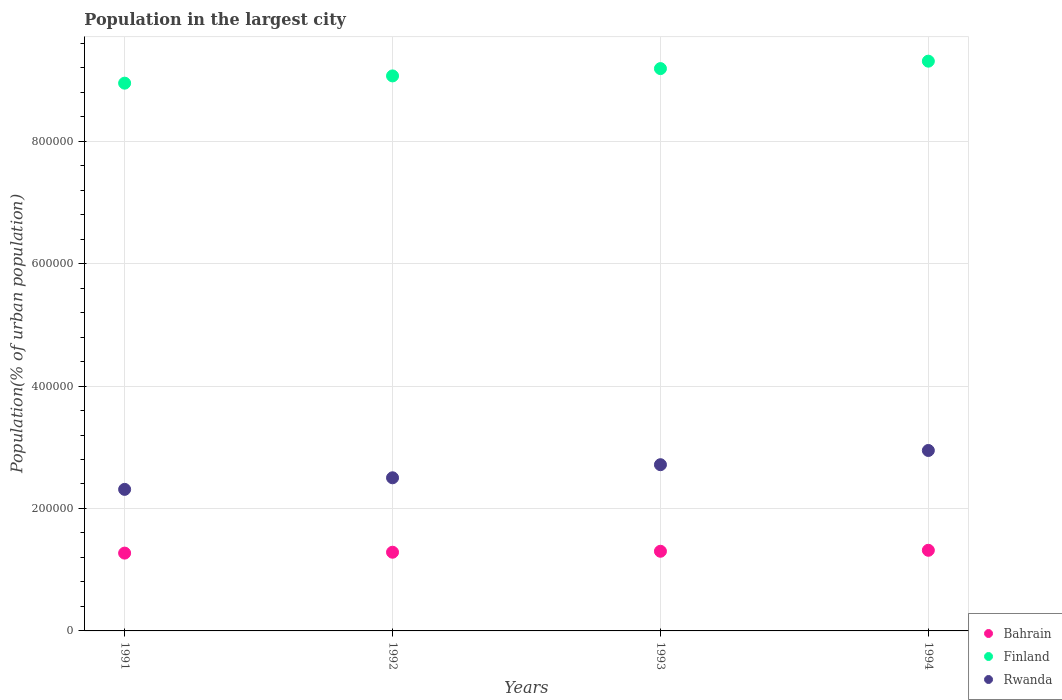What is the population in the largest city in Finland in 1992?
Offer a terse response. 9.07e+05. Across all years, what is the maximum population in the largest city in Bahrain?
Keep it short and to the point. 1.32e+05. Across all years, what is the minimum population in the largest city in Rwanda?
Make the answer very short. 2.31e+05. What is the total population in the largest city in Rwanda in the graph?
Provide a succinct answer. 1.05e+06. What is the difference between the population in the largest city in Rwanda in 1991 and that in 1993?
Your answer should be very brief. -4.03e+04. What is the difference between the population in the largest city in Bahrain in 1993 and the population in the largest city in Rwanda in 1992?
Ensure brevity in your answer.  -1.20e+05. What is the average population in the largest city in Bahrain per year?
Make the answer very short. 1.29e+05. In the year 1992, what is the difference between the population in the largest city in Rwanda and population in the largest city in Bahrain?
Your answer should be compact. 1.22e+05. What is the ratio of the population in the largest city in Bahrain in 1993 to that in 1994?
Keep it short and to the point. 0.99. Is the population in the largest city in Bahrain in 1991 less than that in 1994?
Your answer should be very brief. Yes. Is the difference between the population in the largest city in Rwanda in 1991 and 1994 greater than the difference between the population in the largest city in Bahrain in 1991 and 1994?
Keep it short and to the point. No. What is the difference between the highest and the second highest population in the largest city in Bahrain?
Your response must be concise. 1595. What is the difference between the highest and the lowest population in the largest city in Bahrain?
Your answer should be compact. 4609. In how many years, is the population in the largest city in Finland greater than the average population in the largest city in Finland taken over all years?
Offer a terse response. 2. Does the population in the largest city in Rwanda monotonically increase over the years?
Give a very brief answer. Yes. Is the population in the largest city in Finland strictly greater than the population in the largest city in Rwanda over the years?
Keep it short and to the point. Yes. Is the population in the largest city in Bahrain strictly less than the population in the largest city in Rwanda over the years?
Give a very brief answer. Yes. How many dotlines are there?
Ensure brevity in your answer.  3. Are the values on the major ticks of Y-axis written in scientific E-notation?
Give a very brief answer. No. Where does the legend appear in the graph?
Offer a very short reply. Bottom right. How many legend labels are there?
Provide a succinct answer. 3. What is the title of the graph?
Provide a short and direct response. Population in the largest city. What is the label or title of the X-axis?
Give a very brief answer. Years. What is the label or title of the Y-axis?
Offer a terse response. Population(% of urban population). What is the Population(% of urban population) of Bahrain in 1991?
Offer a very short reply. 1.27e+05. What is the Population(% of urban population) of Finland in 1991?
Offer a terse response. 8.95e+05. What is the Population(% of urban population) in Rwanda in 1991?
Keep it short and to the point. 2.31e+05. What is the Population(% of urban population) of Bahrain in 1992?
Make the answer very short. 1.29e+05. What is the Population(% of urban population) in Finland in 1992?
Make the answer very short. 9.07e+05. What is the Population(% of urban population) in Rwanda in 1992?
Your answer should be very brief. 2.50e+05. What is the Population(% of urban population) in Bahrain in 1993?
Give a very brief answer. 1.30e+05. What is the Population(% of urban population) of Finland in 1993?
Your answer should be compact. 9.18e+05. What is the Population(% of urban population) of Rwanda in 1993?
Your answer should be compact. 2.72e+05. What is the Population(% of urban population) of Bahrain in 1994?
Your answer should be compact. 1.32e+05. What is the Population(% of urban population) in Finland in 1994?
Give a very brief answer. 9.31e+05. What is the Population(% of urban population) of Rwanda in 1994?
Provide a short and direct response. 2.95e+05. Across all years, what is the maximum Population(% of urban population) in Bahrain?
Your answer should be compact. 1.32e+05. Across all years, what is the maximum Population(% of urban population) of Finland?
Provide a short and direct response. 9.31e+05. Across all years, what is the maximum Population(% of urban population) in Rwanda?
Give a very brief answer. 2.95e+05. Across all years, what is the minimum Population(% of urban population) in Bahrain?
Keep it short and to the point. 1.27e+05. Across all years, what is the minimum Population(% of urban population) of Finland?
Keep it short and to the point. 8.95e+05. Across all years, what is the minimum Population(% of urban population) in Rwanda?
Your answer should be very brief. 2.31e+05. What is the total Population(% of urban population) in Bahrain in the graph?
Offer a very short reply. 5.17e+05. What is the total Population(% of urban population) of Finland in the graph?
Keep it short and to the point. 3.65e+06. What is the total Population(% of urban population) in Rwanda in the graph?
Make the answer very short. 1.05e+06. What is the difference between the Population(% of urban population) of Bahrain in 1991 and that in 1992?
Ensure brevity in your answer.  -1440. What is the difference between the Population(% of urban population) in Finland in 1991 and that in 1992?
Give a very brief answer. -1.18e+04. What is the difference between the Population(% of urban population) in Rwanda in 1991 and that in 1992?
Make the answer very short. -1.89e+04. What is the difference between the Population(% of urban population) of Bahrain in 1991 and that in 1993?
Provide a short and direct response. -3014. What is the difference between the Population(% of urban population) in Finland in 1991 and that in 1993?
Make the answer very short. -2.38e+04. What is the difference between the Population(% of urban population) of Rwanda in 1991 and that in 1993?
Your answer should be very brief. -4.03e+04. What is the difference between the Population(% of urban population) of Bahrain in 1991 and that in 1994?
Provide a succinct answer. -4609. What is the difference between the Population(% of urban population) in Finland in 1991 and that in 1994?
Offer a terse response. -3.59e+04. What is the difference between the Population(% of urban population) of Rwanda in 1991 and that in 1994?
Ensure brevity in your answer.  -6.35e+04. What is the difference between the Population(% of urban population) of Bahrain in 1992 and that in 1993?
Your answer should be compact. -1574. What is the difference between the Population(% of urban population) of Finland in 1992 and that in 1993?
Your response must be concise. -1.20e+04. What is the difference between the Population(% of urban population) in Rwanda in 1992 and that in 1993?
Provide a short and direct response. -2.14e+04. What is the difference between the Population(% of urban population) in Bahrain in 1992 and that in 1994?
Your answer should be very brief. -3169. What is the difference between the Population(% of urban population) of Finland in 1992 and that in 1994?
Provide a succinct answer. -2.41e+04. What is the difference between the Population(% of urban population) in Rwanda in 1992 and that in 1994?
Your answer should be very brief. -4.46e+04. What is the difference between the Population(% of urban population) in Bahrain in 1993 and that in 1994?
Give a very brief answer. -1595. What is the difference between the Population(% of urban population) of Finland in 1993 and that in 1994?
Offer a terse response. -1.21e+04. What is the difference between the Population(% of urban population) of Rwanda in 1993 and that in 1994?
Provide a succinct answer. -2.32e+04. What is the difference between the Population(% of urban population) of Bahrain in 1991 and the Population(% of urban population) of Finland in 1992?
Make the answer very short. -7.79e+05. What is the difference between the Population(% of urban population) of Bahrain in 1991 and the Population(% of urban population) of Rwanda in 1992?
Make the answer very short. -1.23e+05. What is the difference between the Population(% of urban population) of Finland in 1991 and the Population(% of urban population) of Rwanda in 1992?
Give a very brief answer. 6.45e+05. What is the difference between the Population(% of urban population) of Bahrain in 1991 and the Population(% of urban population) of Finland in 1993?
Make the answer very short. -7.91e+05. What is the difference between the Population(% of urban population) in Bahrain in 1991 and the Population(% of urban population) in Rwanda in 1993?
Make the answer very short. -1.44e+05. What is the difference between the Population(% of urban population) in Finland in 1991 and the Population(% of urban population) in Rwanda in 1993?
Ensure brevity in your answer.  6.23e+05. What is the difference between the Population(% of urban population) of Bahrain in 1991 and the Population(% of urban population) of Finland in 1994?
Provide a short and direct response. -8.04e+05. What is the difference between the Population(% of urban population) in Bahrain in 1991 and the Population(% of urban population) in Rwanda in 1994?
Offer a very short reply. -1.68e+05. What is the difference between the Population(% of urban population) in Finland in 1991 and the Population(% of urban population) in Rwanda in 1994?
Ensure brevity in your answer.  6.00e+05. What is the difference between the Population(% of urban population) of Bahrain in 1992 and the Population(% of urban population) of Finland in 1993?
Provide a succinct answer. -7.90e+05. What is the difference between the Population(% of urban population) in Bahrain in 1992 and the Population(% of urban population) in Rwanda in 1993?
Your answer should be compact. -1.43e+05. What is the difference between the Population(% of urban population) in Finland in 1992 and the Population(% of urban population) in Rwanda in 1993?
Keep it short and to the point. 6.35e+05. What is the difference between the Population(% of urban population) in Bahrain in 1992 and the Population(% of urban population) in Finland in 1994?
Make the answer very short. -8.02e+05. What is the difference between the Population(% of urban population) of Bahrain in 1992 and the Population(% of urban population) of Rwanda in 1994?
Give a very brief answer. -1.66e+05. What is the difference between the Population(% of urban population) in Finland in 1992 and the Population(% of urban population) in Rwanda in 1994?
Your answer should be compact. 6.12e+05. What is the difference between the Population(% of urban population) in Bahrain in 1993 and the Population(% of urban population) in Finland in 1994?
Provide a short and direct response. -8.00e+05. What is the difference between the Population(% of urban population) in Bahrain in 1993 and the Population(% of urban population) in Rwanda in 1994?
Ensure brevity in your answer.  -1.65e+05. What is the difference between the Population(% of urban population) of Finland in 1993 and the Population(% of urban population) of Rwanda in 1994?
Offer a terse response. 6.24e+05. What is the average Population(% of urban population) in Bahrain per year?
Your response must be concise. 1.29e+05. What is the average Population(% of urban population) of Finland per year?
Keep it short and to the point. 9.13e+05. What is the average Population(% of urban population) in Rwanda per year?
Offer a very short reply. 2.62e+05. In the year 1991, what is the difference between the Population(% of urban population) of Bahrain and Population(% of urban population) of Finland?
Make the answer very short. -7.68e+05. In the year 1991, what is the difference between the Population(% of urban population) of Bahrain and Population(% of urban population) of Rwanda?
Offer a very short reply. -1.04e+05. In the year 1991, what is the difference between the Population(% of urban population) of Finland and Population(% of urban population) of Rwanda?
Ensure brevity in your answer.  6.64e+05. In the year 1992, what is the difference between the Population(% of urban population) in Bahrain and Population(% of urban population) in Finland?
Your response must be concise. -7.78e+05. In the year 1992, what is the difference between the Population(% of urban population) in Bahrain and Population(% of urban population) in Rwanda?
Your answer should be compact. -1.22e+05. In the year 1992, what is the difference between the Population(% of urban population) in Finland and Population(% of urban population) in Rwanda?
Offer a very short reply. 6.56e+05. In the year 1993, what is the difference between the Population(% of urban population) in Bahrain and Population(% of urban population) in Finland?
Offer a very short reply. -7.88e+05. In the year 1993, what is the difference between the Population(% of urban population) of Bahrain and Population(% of urban population) of Rwanda?
Offer a terse response. -1.41e+05. In the year 1993, what is the difference between the Population(% of urban population) in Finland and Population(% of urban population) in Rwanda?
Your answer should be compact. 6.47e+05. In the year 1994, what is the difference between the Population(% of urban population) in Bahrain and Population(% of urban population) in Finland?
Make the answer very short. -7.99e+05. In the year 1994, what is the difference between the Population(% of urban population) of Bahrain and Population(% of urban population) of Rwanda?
Make the answer very short. -1.63e+05. In the year 1994, what is the difference between the Population(% of urban population) of Finland and Population(% of urban population) of Rwanda?
Your response must be concise. 6.36e+05. What is the ratio of the Population(% of urban population) in Bahrain in 1991 to that in 1992?
Provide a succinct answer. 0.99. What is the ratio of the Population(% of urban population) in Finland in 1991 to that in 1992?
Offer a very short reply. 0.99. What is the ratio of the Population(% of urban population) in Rwanda in 1991 to that in 1992?
Your response must be concise. 0.92. What is the ratio of the Population(% of urban population) of Bahrain in 1991 to that in 1993?
Your response must be concise. 0.98. What is the ratio of the Population(% of urban population) of Finland in 1991 to that in 1993?
Your answer should be compact. 0.97. What is the ratio of the Population(% of urban population) in Rwanda in 1991 to that in 1993?
Your answer should be compact. 0.85. What is the ratio of the Population(% of urban population) in Finland in 1991 to that in 1994?
Provide a short and direct response. 0.96. What is the ratio of the Population(% of urban population) of Rwanda in 1991 to that in 1994?
Offer a terse response. 0.78. What is the ratio of the Population(% of urban population) in Bahrain in 1992 to that in 1993?
Your answer should be very brief. 0.99. What is the ratio of the Population(% of urban population) of Finland in 1992 to that in 1993?
Your response must be concise. 0.99. What is the ratio of the Population(% of urban population) of Rwanda in 1992 to that in 1993?
Offer a very short reply. 0.92. What is the ratio of the Population(% of urban population) of Bahrain in 1992 to that in 1994?
Make the answer very short. 0.98. What is the ratio of the Population(% of urban population) in Finland in 1992 to that in 1994?
Provide a short and direct response. 0.97. What is the ratio of the Population(% of urban population) of Rwanda in 1992 to that in 1994?
Your answer should be compact. 0.85. What is the ratio of the Population(% of urban population) of Bahrain in 1993 to that in 1994?
Keep it short and to the point. 0.99. What is the ratio of the Population(% of urban population) in Rwanda in 1993 to that in 1994?
Ensure brevity in your answer.  0.92. What is the difference between the highest and the second highest Population(% of urban population) of Bahrain?
Ensure brevity in your answer.  1595. What is the difference between the highest and the second highest Population(% of urban population) in Finland?
Your answer should be very brief. 1.21e+04. What is the difference between the highest and the second highest Population(% of urban population) in Rwanda?
Provide a succinct answer. 2.32e+04. What is the difference between the highest and the lowest Population(% of urban population) in Bahrain?
Ensure brevity in your answer.  4609. What is the difference between the highest and the lowest Population(% of urban population) of Finland?
Make the answer very short. 3.59e+04. What is the difference between the highest and the lowest Population(% of urban population) of Rwanda?
Your answer should be compact. 6.35e+04. 